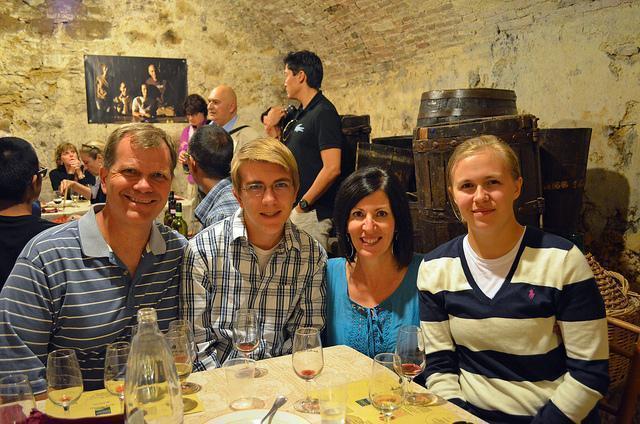What pattern is the young guy's shirt?
Pick the right solution, then justify: 'Answer: answer
Rationale: rationale.'
Options: Stripes, tartan, checked, plaid. Answer: plaid.
Rationale: It has different stripes crossing each other in a pattern 